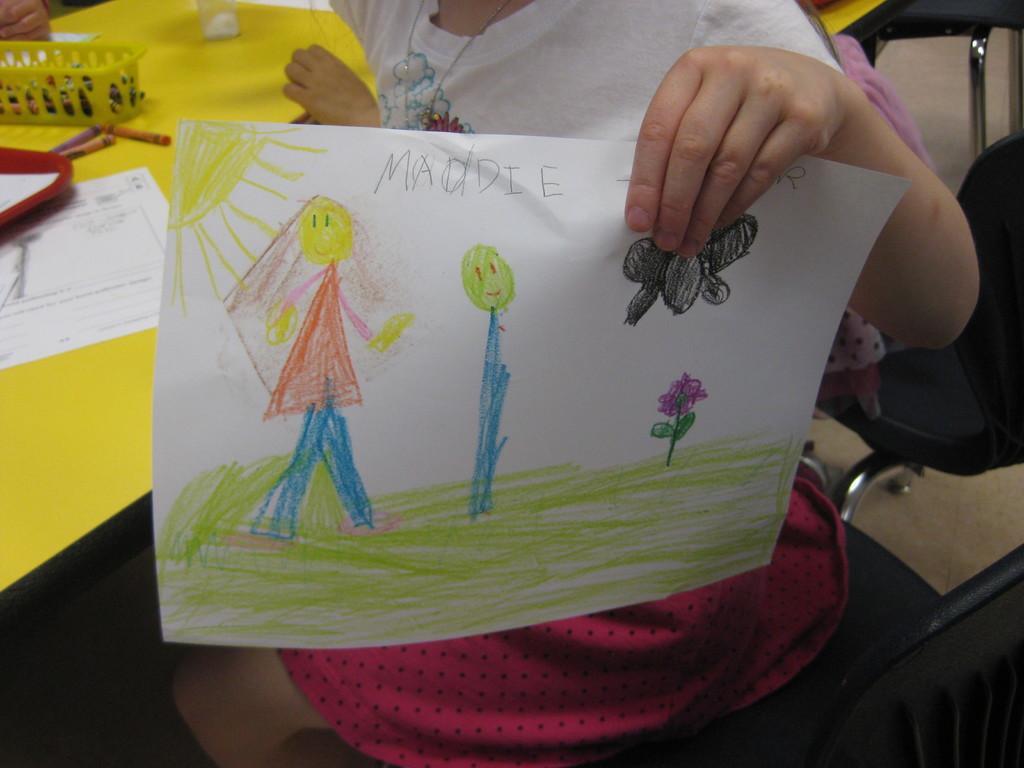Describe this image in one or two sentences. In this image we can see the hand of a girl holding the paper. Here we can see the drawing in the paper. Here we can see the table. Here we can see a paper, sketches and a plastic basket on the table. Here we can see the chairs on the right side. 